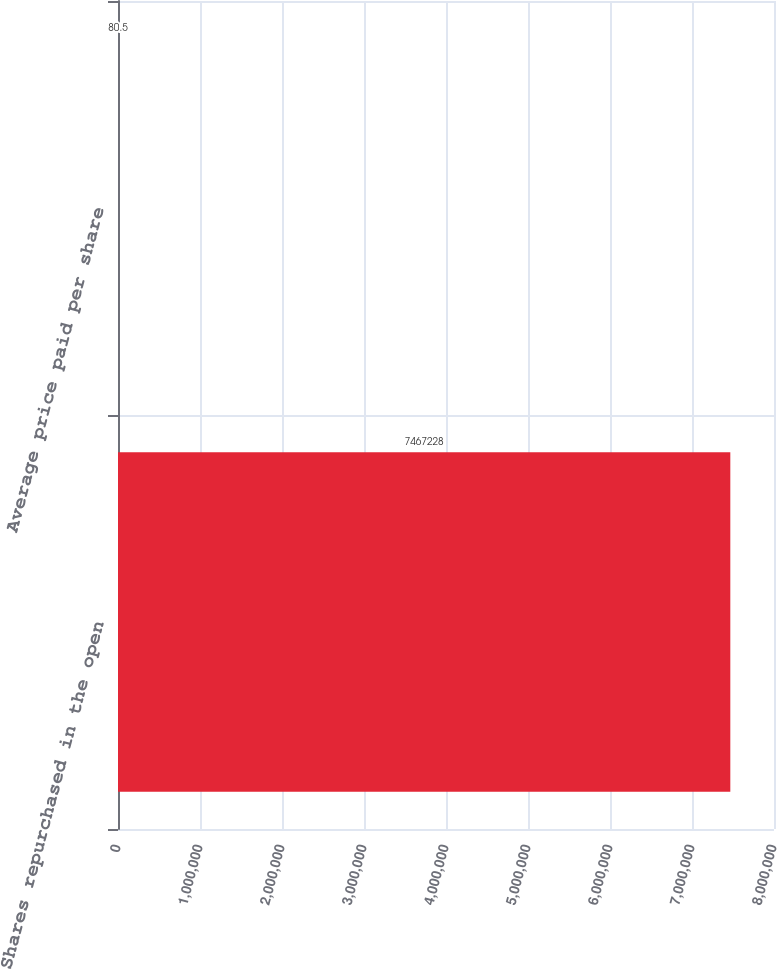Convert chart to OTSL. <chart><loc_0><loc_0><loc_500><loc_500><bar_chart><fcel>Shares repurchased in the open<fcel>Average price paid per share<nl><fcel>7.46723e+06<fcel>80.5<nl></chart> 